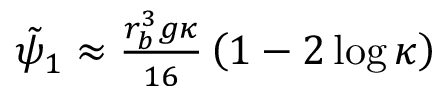<formula> <loc_0><loc_0><loc_500><loc_500>\begin{array} { r } { \tilde { \psi } _ { 1 } \approx \frac { r _ { b } ^ { 3 } g \kappa } { 1 6 } \left ( 1 - 2 \log \kappa \right ) } \end{array}</formula> 